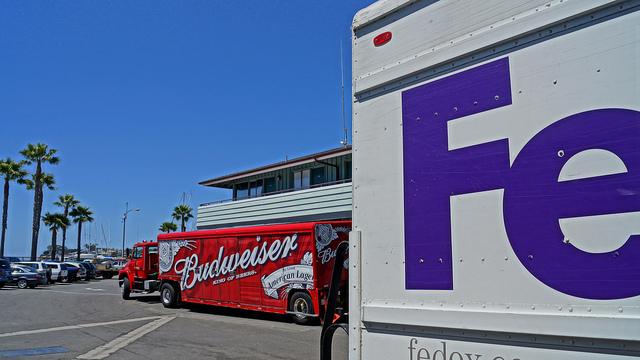Is parking allowed?
Be succinct. Yes. Where is the truck's company located?
Answer briefly. Florida. What is the geographic feature in the background?
Short answer required. Beach. What type of food is in this truck?
Be succinct. Beer. What does the vendor offer?
Concise answer only. Beer. What is the red truck advertising?
Quick response, please. Budweiser. What kind of trees are shown?
Give a very brief answer. Palm. What color is the truck?
Concise answer only. Red. Is there a package being delivered?
Concise answer only. Yes. 